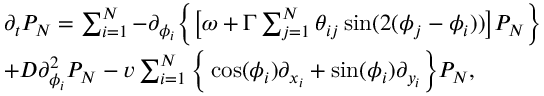<formula> <loc_0><loc_0><loc_500><loc_500>\begin{array} { r l } & { \partial _ { t } P _ { N } = \sum _ { i = 1 } ^ { N } - \partial _ { \phi _ { i } } \left \{ \left [ \omega + \Gamma \sum _ { j = 1 } ^ { N } \theta _ { i j } \sin ( 2 ( \phi _ { j } - \phi _ { i } ) ) \right ] P _ { N } \right \} } \\ & { + D \partial _ { \phi _ { i } } ^ { 2 } P _ { N } - v \sum _ { i = 1 } ^ { N } \left \{ \cos ( \phi _ { i } ) \partial _ { x _ { i } } + \sin ( \phi _ { i } ) \partial _ { y _ { i } } \right \} P _ { N } , } \end{array}</formula> 